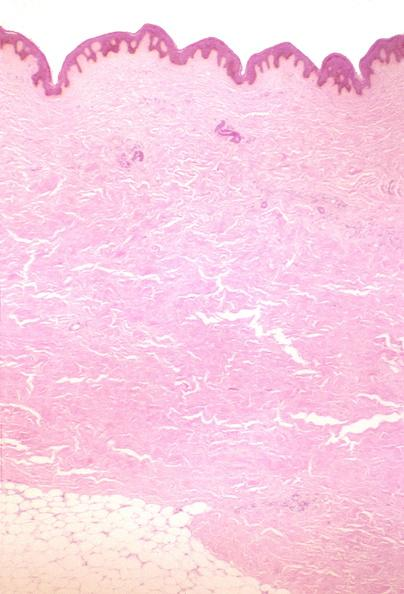does soft tissue show scleroderma?
Answer the question using a single word or phrase. No 